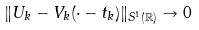Convert formula to latex. <formula><loc_0><loc_0><loc_500><loc_500>\| U _ { k } - V _ { k } ( \cdot - t _ { k } ) \| _ { S ^ { 1 } ( \mathbb { R } ) } \to 0</formula> 